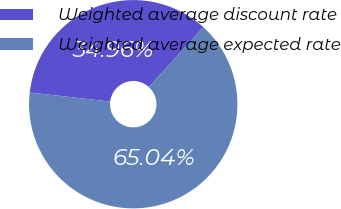Convert chart to OTSL. <chart><loc_0><loc_0><loc_500><loc_500><pie_chart><fcel>Weighted average discount rate<fcel>Weighted average expected rate<nl><fcel>34.96%<fcel>65.04%<nl></chart> 